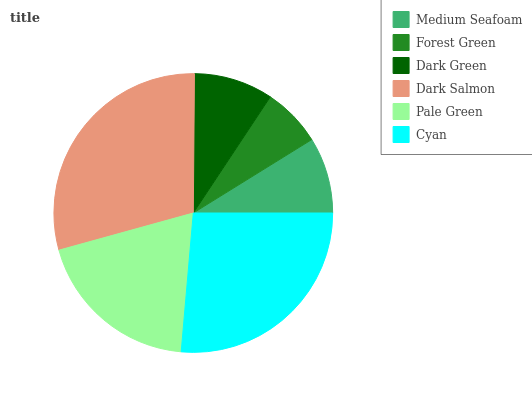Is Forest Green the minimum?
Answer yes or no. Yes. Is Dark Salmon the maximum?
Answer yes or no. Yes. Is Dark Green the minimum?
Answer yes or no. No. Is Dark Green the maximum?
Answer yes or no. No. Is Dark Green greater than Forest Green?
Answer yes or no. Yes. Is Forest Green less than Dark Green?
Answer yes or no. Yes. Is Forest Green greater than Dark Green?
Answer yes or no. No. Is Dark Green less than Forest Green?
Answer yes or no. No. Is Pale Green the high median?
Answer yes or no. Yes. Is Dark Green the low median?
Answer yes or no. Yes. Is Cyan the high median?
Answer yes or no. No. Is Dark Salmon the low median?
Answer yes or no. No. 